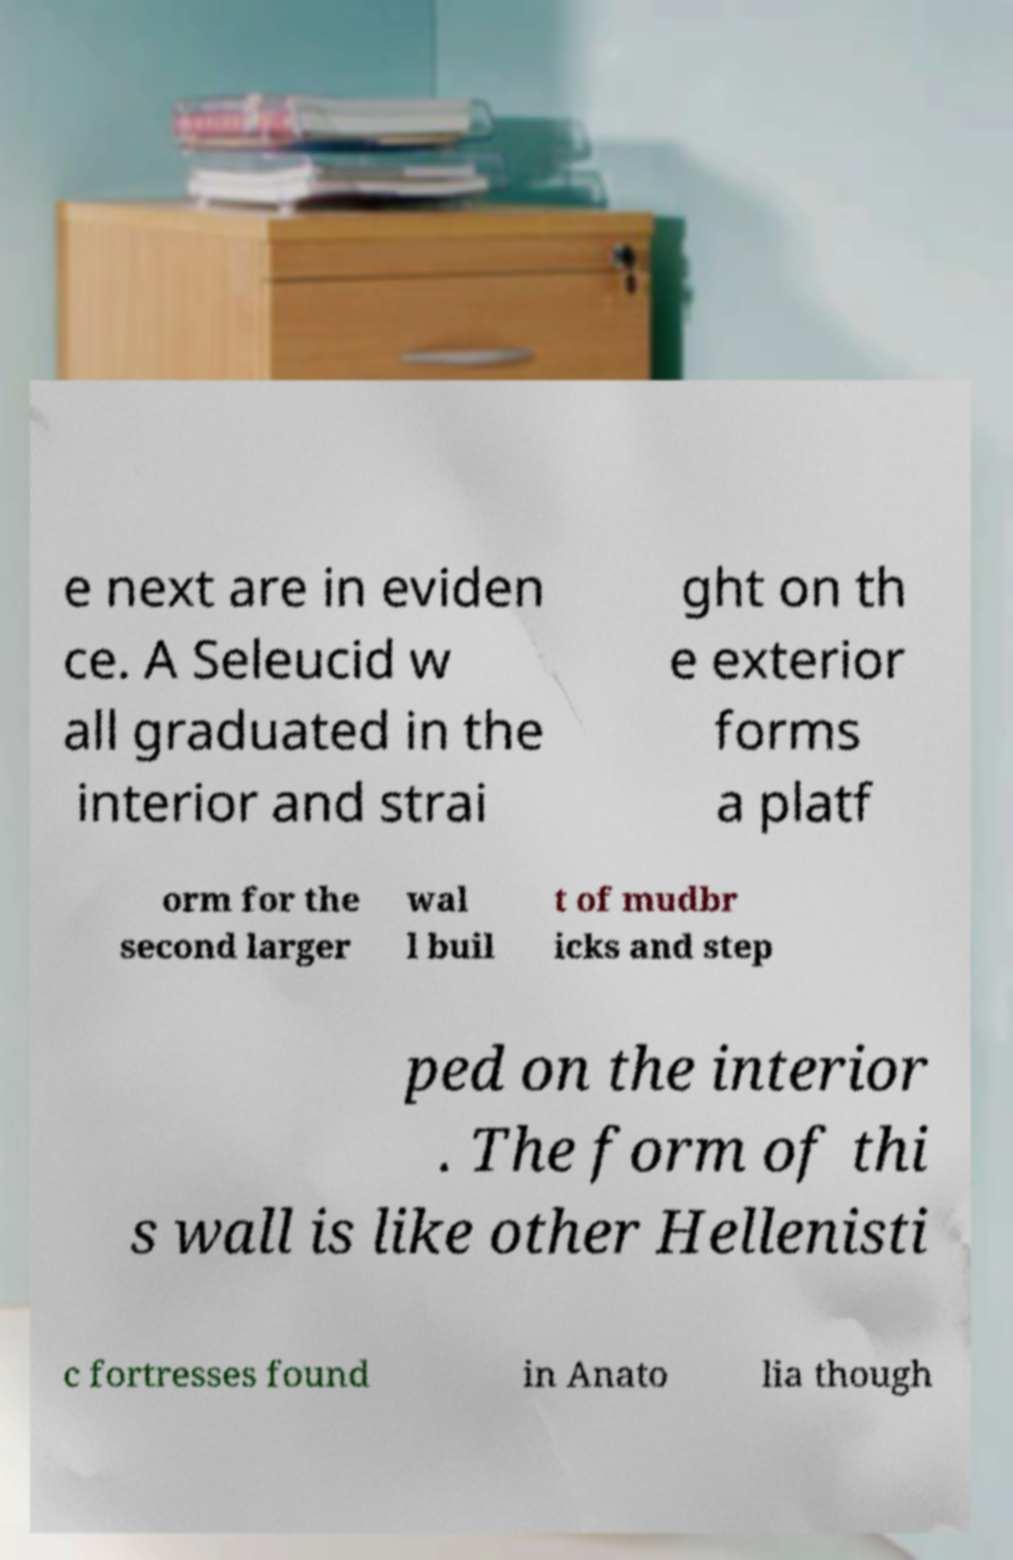I need the written content from this picture converted into text. Can you do that? e next are in eviden ce. A Seleucid w all graduated in the interior and strai ght on th e exterior forms a platf orm for the second larger wal l buil t of mudbr icks and step ped on the interior . The form of thi s wall is like other Hellenisti c fortresses found in Anato lia though 